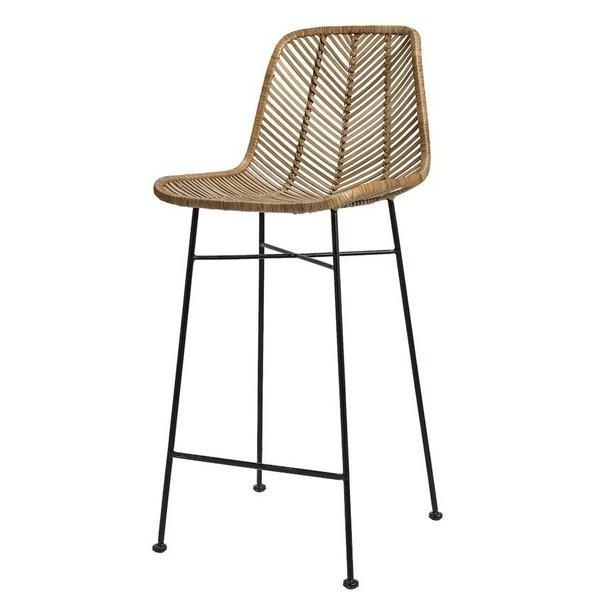Given this bar stool's design, what kind of accessories or additions could enhance its functionality or aesthetic? The bar stool’s design offers a blank canvas for various accessories and additions that can enhance both its functionality and aesthetic appeal. To increase comfort, consider adding a seat cushion or a throw pillow in a complementary color or pattern, providing extra padding for longer sitting periods. Foot pads or gliders on the legs can protect floors from scratches and facilitate easier movement of the stool. For a touch of personal style, you might wrap small sections of the metal legs with decorative rope or attach a small hanging basket underneath the seat to hold small items like napkins or coasters. These additions not only increase comfort and usability but also allow the bar stool to fit seamlessly into diverse decor styles. 